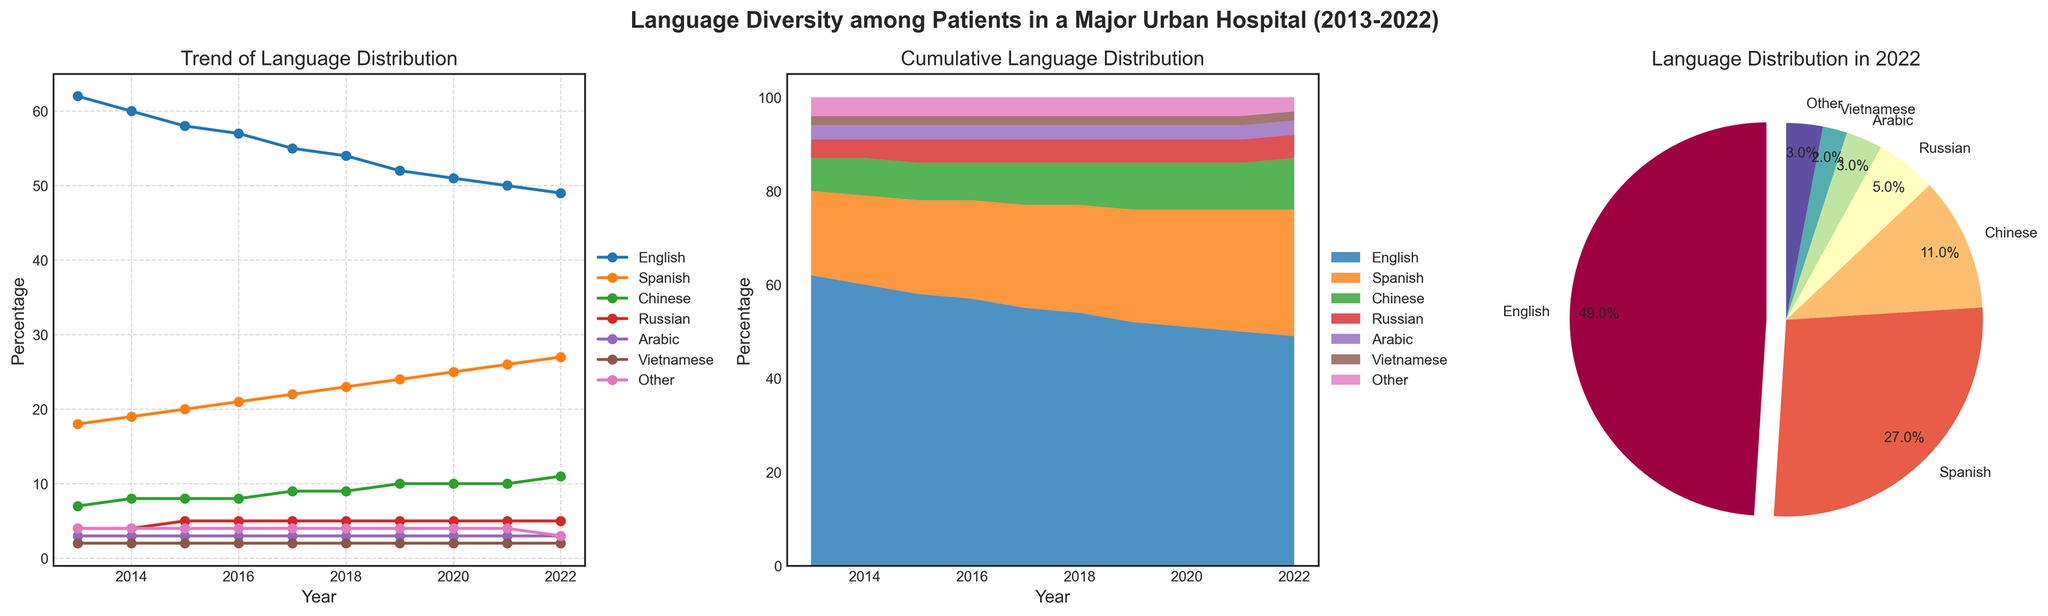What is the percentage of patients who spoke English in 2022? Look at the pie chart and find the segment labeled "English." The percentage is annotated next to the label.
Answer: 49% Which language saw the most significant increase in patient percentage from 2013 to 2022? Compare the lines in the line plot from 2013 to 2022. Identify the line with the steepest positive slope.
Answer: Spanish How did the percentage of patients speaking Vietnamese change from 2013 to 2022? Refer to the line plot. Find the line corresponding to "Vietnamese" and observe the change from 2013 to 2022. The value remains consistent at 2% except for a slight dip to 3% in 2022.
Answer: Decreased from 2% to 3% Which year had the least percentage of patients speaking English? Look at the line plot tracking English. Identify the lowest value point and its corresponding year.
Answer: 2022 What is the overall trend for patients speaking Arabic from 2013 to 2022? Examine the line plot for "Arabic." Note the flat trend line with little to no change.
Answer: Consistent at 3% In the stacked area chart, which year did Spanish-speaking patients first exceed 20%? Locate the boundary of the Spanish area in the stacked plot and track when it first crosses the 20% threshold on the Y-axis.
Answer: 2015 Comparing Chinese and Russian, which group's percentage remained more stable over the past decade? Compare the lines of "Chinese" and "Russian" in the line plot. "Russian" has little fluctuation compared to "Chinese."
Answer: Russian In 2020, what is the combined percentage of patients speaking Arabic and Vietnamese? Refer to the line plot and find the percentages for Arabic and Vietnamese in 2020, then add them together (3% + 2%).
Answer: 5% 